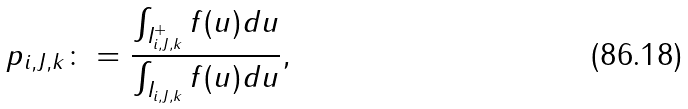<formula> <loc_0><loc_0><loc_500><loc_500>p _ { i , J , k } \colon = \frac { \int _ { I _ { i , J , k } ^ { + } } f ( u ) d u } { \int _ { I _ { i , J , k } } f ( u ) d u } ,</formula> 